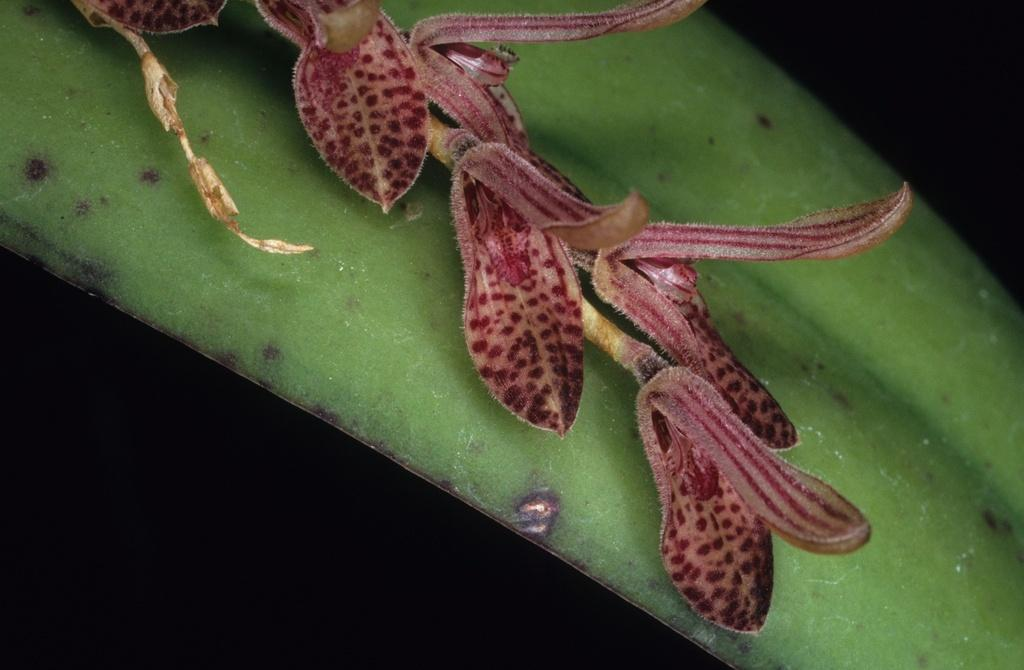What is the main subject of the image? There is a flower in the image. Can you describe the flower's location? The flower is on a plant. How many people are involved in the fight depicted in the image? There is no fight depicted in the image; it features a flower on a plant. What type of kite can be seen flying in the image? There is no kite present in the image. 